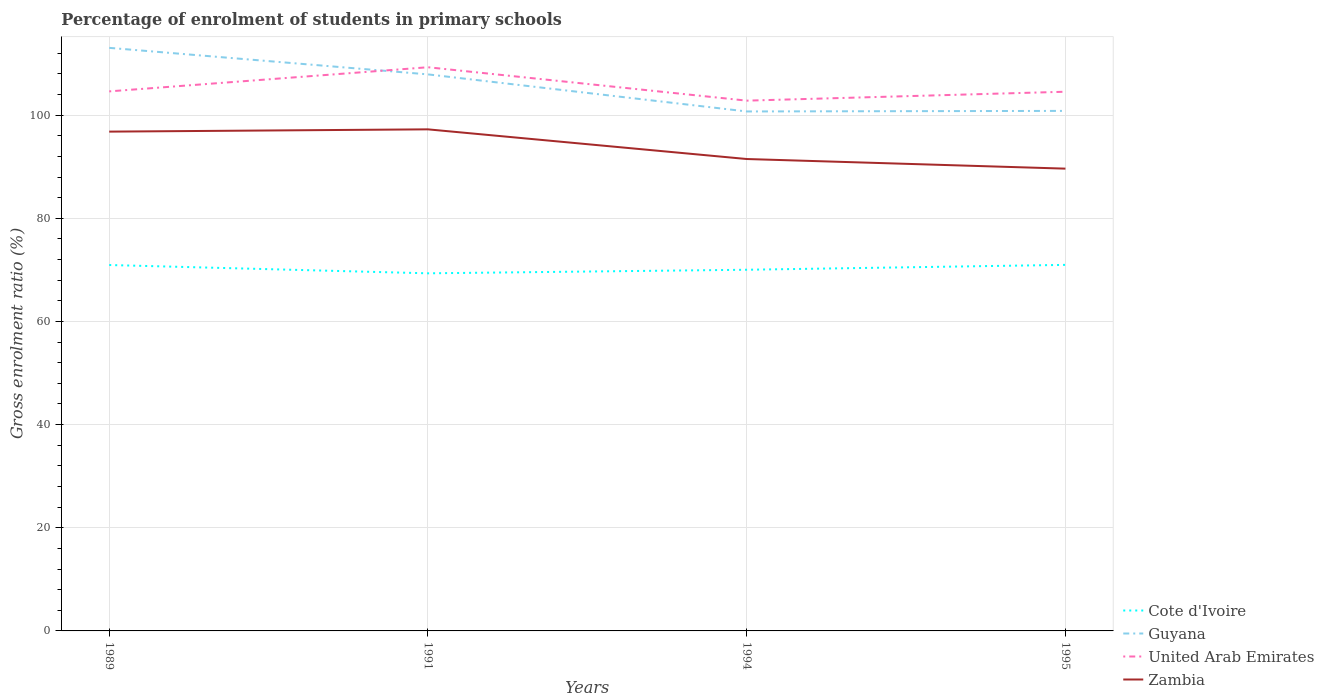How many different coloured lines are there?
Make the answer very short. 4. Is the number of lines equal to the number of legend labels?
Give a very brief answer. Yes. Across all years, what is the maximum percentage of students enrolled in primary schools in United Arab Emirates?
Provide a short and direct response. 102.82. What is the total percentage of students enrolled in primary schools in Zambia in the graph?
Offer a very short reply. 5.31. What is the difference between the highest and the second highest percentage of students enrolled in primary schools in Zambia?
Keep it short and to the point. 7.62. What is the difference between the highest and the lowest percentage of students enrolled in primary schools in Zambia?
Provide a short and direct response. 2. Is the percentage of students enrolled in primary schools in Cote d'Ivoire strictly greater than the percentage of students enrolled in primary schools in Zambia over the years?
Give a very brief answer. Yes. How many lines are there?
Provide a short and direct response. 4. How many years are there in the graph?
Your answer should be compact. 4. What is the difference between two consecutive major ticks on the Y-axis?
Your answer should be very brief. 20. Does the graph contain any zero values?
Your response must be concise. No. Does the graph contain grids?
Make the answer very short. Yes. How many legend labels are there?
Offer a very short reply. 4. What is the title of the graph?
Keep it short and to the point. Percentage of enrolment of students in primary schools. Does "Turkmenistan" appear as one of the legend labels in the graph?
Offer a very short reply. No. What is the label or title of the Y-axis?
Make the answer very short. Gross enrolment ratio (%). What is the Gross enrolment ratio (%) in Cote d'Ivoire in 1989?
Offer a terse response. 70.95. What is the Gross enrolment ratio (%) in Guyana in 1989?
Provide a succinct answer. 113.06. What is the Gross enrolment ratio (%) of United Arab Emirates in 1989?
Keep it short and to the point. 104.62. What is the Gross enrolment ratio (%) in Zambia in 1989?
Offer a terse response. 96.81. What is the Gross enrolment ratio (%) in Cote d'Ivoire in 1991?
Ensure brevity in your answer.  69.34. What is the Gross enrolment ratio (%) in Guyana in 1991?
Provide a succinct answer. 107.91. What is the Gross enrolment ratio (%) of United Arab Emirates in 1991?
Provide a short and direct response. 109.3. What is the Gross enrolment ratio (%) in Zambia in 1991?
Offer a terse response. 97.25. What is the Gross enrolment ratio (%) of Cote d'Ivoire in 1994?
Provide a short and direct response. 70.03. What is the Gross enrolment ratio (%) of Guyana in 1994?
Give a very brief answer. 100.72. What is the Gross enrolment ratio (%) in United Arab Emirates in 1994?
Your answer should be compact. 102.82. What is the Gross enrolment ratio (%) in Zambia in 1994?
Keep it short and to the point. 91.5. What is the Gross enrolment ratio (%) of Cote d'Ivoire in 1995?
Make the answer very short. 70.98. What is the Gross enrolment ratio (%) in Guyana in 1995?
Keep it short and to the point. 100.83. What is the Gross enrolment ratio (%) in United Arab Emirates in 1995?
Keep it short and to the point. 104.55. What is the Gross enrolment ratio (%) in Zambia in 1995?
Your answer should be compact. 89.64. Across all years, what is the maximum Gross enrolment ratio (%) of Cote d'Ivoire?
Ensure brevity in your answer.  70.98. Across all years, what is the maximum Gross enrolment ratio (%) of Guyana?
Ensure brevity in your answer.  113.06. Across all years, what is the maximum Gross enrolment ratio (%) of United Arab Emirates?
Make the answer very short. 109.3. Across all years, what is the maximum Gross enrolment ratio (%) of Zambia?
Give a very brief answer. 97.25. Across all years, what is the minimum Gross enrolment ratio (%) in Cote d'Ivoire?
Your answer should be compact. 69.34. Across all years, what is the minimum Gross enrolment ratio (%) in Guyana?
Ensure brevity in your answer.  100.72. Across all years, what is the minimum Gross enrolment ratio (%) in United Arab Emirates?
Your answer should be very brief. 102.82. Across all years, what is the minimum Gross enrolment ratio (%) in Zambia?
Ensure brevity in your answer.  89.64. What is the total Gross enrolment ratio (%) of Cote d'Ivoire in the graph?
Provide a short and direct response. 281.3. What is the total Gross enrolment ratio (%) in Guyana in the graph?
Your answer should be very brief. 422.53. What is the total Gross enrolment ratio (%) in United Arab Emirates in the graph?
Provide a succinct answer. 421.28. What is the total Gross enrolment ratio (%) in Zambia in the graph?
Offer a terse response. 375.21. What is the difference between the Gross enrolment ratio (%) of Cote d'Ivoire in 1989 and that in 1991?
Make the answer very short. 1.61. What is the difference between the Gross enrolment ratio (%) of Guyana in 1989 and that in 1991?
Keep it short and to the point. 5.15. What is the difference between the Gross enrolment ratio (%) in United Arab Emirates in 1989 and that in 1991?
Your response must be concise. -4.68. What is the difference between the Gross enrolment ratio (%) of Zambia in 1989 and that in 1991?
Ensure brevity in your answer.  -0.44. What is the difference between the Gross enrolment ratio (%) of Cote d'Ivoire in 1989 and that in 1994?
Provide a short and direct response. 0.92. What is the difference between the Gross enrolment ratio (%) in Guyana in 1989 and that in 1994?
Offer a terse response. 12.33. What is the difference between the Gross enrolment ratio (%) in United Arab Emirates in 1989 and that in 1994?
Provide a succinct answer. 1.8. What is the difference between the Gross enrolment ratio (%) in Zambia in 1989 and that in 1994?
Offer a terse response. 5.31. What is the difference between the Gross enrolment ratio (%) in Cote d'Ivoire in 1989 and that in 1995?
Give a very brief answer. -0.03. What is the difference between the Gross enrolment ratio (%) in Guyana in 1989 and that in 1995?
Give a very brief answer. 12.22. What is the difference between the Gross enrolment ratio (%) in United Arab Emirates in 1989 and that in 1995?
Make the answer very short. 0.07. What is the difference between the Gross enrolment ratio (%) in Zambia in 1989 and that in 1995?
Give a very brief answer. 7.18. What is the difference between the Gross enrolment ratio (%) in Cote d'Ivoire in 1991 and that in 1994?
Your answer should be compact. -0.69. What is the difference between the Gross enrolment ratio (%) of Guyana in 1991 and that in 1994?
Give a very brief answer. 7.19. What is the difference between the Gross enrolment ratio (%) in United Arab Emirates in 1991 and that in 1994?
Your answer should be compact. 6.48. What is the difference between the Gross enrolment ratio (%) in Zambia in 1991 and that in 1994?
Your response must be concise. 5.75. What is the difference between the Gross enrolment ratio (%) in Cote d'Ivoire in 1991 and that in 1995?
Make the answer very short. -1.64. What is the difference between the Gross enrolment ratio (%) of Guyana in 1991 and that in 1995?
Keep it short and to the point. 7.08. What is the difference between the Gross enrolment ratio (%) of United Arab Emirates in 1991 and that in 1995?
Ensure brevity in your answer.  4.75. What is the difference between the Gross enrolment ratio (%) in Zambia in 1991 and that in 1995?
Provide a short and direct response. 7.62. What is the difference between the Gross enrolment ratio (%) of Cote d'Ivoire in 1994 and that in 1995?
Your answer should be compact. -0.95. What is the difference between the Gross enrolment ratio (%) in Guyana in 1994 and that in 1995?
Keep it short and to the point. -0.11. What is the difference between the Gross enrolment ratio (%) in United Arab Emirates in 1994 and that in 1995?
Provide a short and direct response. -1.73. What is the difference between the Gross enrolment ratio (%) in Zambia in 1994 and that in 1995?
Offer a very short reply. 1.87. What is the difference between the Gross enrolment ratio (%) in Cote d'Ivoire in 1989 and the Gross enrolment ratio (%) in Guyana in 1991?
Offer a terse response. -36.96. What is the difference between the Gross enrolment ratio (%) of Cote d'Ivoire in 1989 and the Gross enrolment ratio (%) of United Arab Emirates in 1991?
Ensure brevity in your answer.  -38.35. What is the difference between the Gross enrolment ratio (%) of Cote d'Ivoire in 1989 and the Gross enrolment ratio (%) of Zambia in 1991?
Your answer should be compact. -26.31. What is the difference between the Gross enrolment ratio (%) in Guyana in 1989 and the Gross enrolment ratio (%) in United Arab Emirates in 1991?
Give a very brief answer. 3.76. What is the difference between the Gross enrolment ratio (%) of Guyana in 1989 and the Gross enrolment ratio (%) of Zambia in 1991?
Provide a succinct answer. 15.8. What is the difference between the Gross enrolment ratio (%) of United Arab Emirates in 1989 and the Gross enrolment ratio (%) of Zambia in 1991?
Offer a terse response. 7.36. What is the difference between the Gross enrolment ratio (%) of Cote d'Ivoire in 1989 and the Gross enrolment ratio (%) of Guyana in 1994?
Your response must be concise. -29.77. What is the difference between the Gross enrolment ratio (%) of Cote d'Ivoire in 1989 and the Gross enrolment ratio (%) of United Arab Emirates in 1994?
Make the answer very short. -31.87. What is the difference between the Gross enrolment ratio (%) of Cote d'Ivoire in 1989 and the Gross enrolment ratio (%) of Zambia in 1994?
Provide a short and direct response. -20.55. What is the difference between the Gross enrolment ratio (%) of Guyana in 1989 and the Gross enrolment ratio (%) of United Arab Emirates in 1994?
Make the answer very short. 10.24. What is the difference between the Gross enrolment ratio (%) of Guyana in 1989 and the Gross enrolment ratio (%) of Zambia in 1994?
Your response must be concise. 21.55. What is the difference between the Gross enrolment ratio (%) in United Arab Emirates in 1989 and the Gross enrolment ratio (%) in Zambia in 1994?
Offer a terse response. 13.11. What is the difference between the Gross enrolment ratio (%) of Cote d'Ivoire in 1989 and the Gross enrolment ratio (%) of Guyana in 1995?
Offer a terse response. -29.88. What is the difference between the Gross enrolment ratio (%) in Cote d'Ivoire in 1989 and the Gross enrolment ratio (%) in United Arab Emirates in 1995?
Make the answer very short. -33.6. What is the difference between the Gross enrolment ratio (%) of Cote d'Ivoire in 1989 and the Gross enrolment ratio (%) of Zambia in 1995?
Your answer should be compact. -18.69. What is the difference between the Gross enrolment ratio (%) in Guyana in 1989 and the Gross enrolment ratio (%) in United Arab Emirates in 1995?
Ensure brevity in your answer.  8.51. What is the difference between the Gross enrolment ratio (%) in Guyana in 1989 and the Gross enrolment ratio (%) in Zambia in 1995?
Provide a succinct answer. 23.42. What is the difference between the Gross enrolment ratio (%) in United Arab Emirates in 1989 and the Gross enrolment ratio (%) in Zambia in 1995?
Your response must be concise. 14.98. What is the difference between the Gross enrolment ratio (%) of Cote d'Ivoire in 1991 and the Gross enrolment ratio (%) of Guyana in 1994?
Your answer should be compact. -31.38. What is the difference between the Gross enrolment ratio (%) in Cote d'Ivoire in 1991 and the Gross enrolment ratio (%) in United Arab Emirates in 1994?
Offer a very short reply. -33.48. What is the difference between the Gross enrolment ratio (%) of Cote d'Ivoire in 1991 and the Gross enrolment ratio (%) of Zambia in 1994?
Your answer should be very brief. -22.16. What is the difference between the Gross enrolment ratio (%) in Guyana in 1991 and the Gross enrolment ratio (%) in United Arab Emirates in 1994?
Your answer should be very brief. 5.09. What is the difference between the Gross enrolment ratio (%) of Guyana in 1991 and the Gross enrolment ratio (%) of Zambia in 1994?
Keep it short and to the point. 16.41. What is the difference between the Gross enrolment ratio (%) of United Arab Emirates in 1991 and the Gross enrolment ratio (%) of Zambia in 1994?
Offer a terse response. 17.79. What is the difference between the Gross enrolment ratio (%) of Cote d'Ivoire in 1991 and the Gross enrolment ratio (%) of Guyana in 1995?
Provide a succinct answer. -31.49. What is the difference between the Gross enrolment ratio (%) of Cote d'Ivoire in 1991 and the Gross enrolment ratio (%) of United Arab Emirates in 1995?
Offer a very short reply. -35.21. What is the difference between the Gross enrolment ratio (%) in Cote d'Ivoire in 1991 and the Gross enrolment ratio (%) in Zambia in 1995?
Offer a very short reply. -20.3. What is the difference between the Gross enrolment ratio (%) of Guyana in 1991 and the Gross enrolment ratio (%) of United Arab Emirates in 1995?
Your answer should be compact. 3.36. What is the difference between the Gross enrolment ratio (%) of Guyana in 1991 and the Gross enrolment ratio (%) of Zambia in 1995?
Make the answer very short. 18.28. What is the difference between the Gross enrolment ratio (%) of United Arab Emirates in 1991 and the Gross enrolment ratio (%) of Zambia in 1995?
Offer a terse response. 19.66. What is the difference between the Gross enrolment ratio (%) in Cote d'Ivoire in 1994 and the Gross enrolment ratio (%) in Guyana in 1995?
Offer a very short reply. -30.8. What is the difference between the Gross enrolment ratio (%) in Cote d'Ivoire in 1994 and the Gross enrolment ratio (%) in United Arab Emirates in 1995?
Ensure brevity in your answer.  -34.52. What is the difference between the Gross enrolment ratio (%) of Cote d'Ivoire in 1994 and the Gross enrolment ratio (%) of Zambia in 1995?
Offer a terse response. -19.61. What is the difference between the Gross enrolment ratio (%) in Guyana in 1994 and the Gross enrolment ratio (%) in United Arab Emirates in 1995?
Provide a short and direct response. -3.83. What is the difference between the Gross enrolment ratio (%) of Guyana in 1994 and the Gross enrolment ratio (%) of Zambia in 1995?
Offer a terse response. 11.09. What is the difference between the Gross enrolment ratio (%) in United Arab Emirates in 1994 and the Gross enrolment ratio (%) in Zambia in 1995?
Offer a terse response. 13.18. What is the average Gross enrolment ratio (%) in Cote d'Ivoire per year?
Offer a terse response. 70.32. What is the average Gross enrolment ratio (%) of Guyana per year?
Provide a short and direct response. 105.63. What is the average Gross enrolment ratio (%) of United Arab Emirates per year?
Keep it short and to the point. 105.32. What is the average Gross enrolment ratio (%) in Zambia per year?
Make the answer very short. 93.8. In the year 1989, what is the difference between the Gross enrolment ratio (%) of Cote d'Ivoire and Gross enrolment ratio (%) of Guyana?
Ensure brevity in your answer.  -42.11. In the year 1989, what is the difference between the Gross enrolment ratio (%) of Cote d'Ivoire and Gross enrolment ratio (%) of United Arab Emirates?
Keep it short and to the point. -33.67. In the year 1989, what is the difference between the Gross enrolment ratio (%) in Cote d'Ivoire and Gross enrolment ratio (%) in Zambia?
Provide a short and direct response. -25.86. In the year 1989, what is the difference between the Gross enrolment ratio (%) of Guyana and Gross enrolment ratio (%) of United Arab Emirates?
Ensure brevity in your answer.  8.44. In the year 1989, what is the difference between the Gross enrolment ratio (%) of Guyana and Gross enrolment ratio (%) of Zambia?
Your answer should be very brief. 16.24. In the year 1989, what is the difference between the Gross enrolment ratio (%) in United Arab Emirates and Gross enrolment ratio (%) in Zambia?
Ensure brevity in your answer.  7.8. In the year 1991, what is the difference between the Gross enrolment ratio (%) of Cote d'Ivoire and Gross enrolment ratio (%) of Guyana?
Your response must be concise. -38.57. In the year 1991, what is the difference between the Gross enrolment ratio (%) in Cote d'Ivoire and Gross enrolment ratio (%) in United Arab Emirates?
Make the answer very short. -39.96. In the year 1991, what is the difference between the Gross enrolment ratio (%) in Cote d'Ivoire and Gross enrolment ratio (%) in Zambia?
Provide a succinct answer. -27.91. In the year 1991, what is the difference between the Gross enrolment ratio (%) of Guyana and Gross enrolment ratio (%) of United Arab Emirates?
Your answer should be compact. -1.38. In the year 1991, what is the difference between the Gross enrolment ratio (%) of Guyana and Gross enrolment ratio (%) of Zambia?
Your answer should be compact. 10.66. In the year 1991, what is the difference between the Gross enrolment ratio (%) in United Arab Emirates and Gross enrolment ratio (%) in Zambia?
Your answer should be very brief. 12.04. In the year 1994, what is the difference between the Gross enrolment ratio (%) of Cote d'Ivoire and Gross enrolment ratio (%) of Guyana?
Keep it short and to the point. -30.69. In the year 1994, what is the difference between the Gross enrolment ratio (%) in Cote d'Ivoire and Gross enrolment ratio (%) in United Arab Emirates?
Offer a terse response. -32.79. In the year 1994, what is the difference between the Gross enrolment ratio (%) in Cote d'Ivoire and Gross enrolment ratio (%) in Zambia?
Ensure brevity in your answer.  -21.47. In the year 1994, what is the difference between the Gross enrolment ratio (%) of Guyana and Gross enrolment ratio (%) of United Arab Emirates?
Your answer should be compact. -2.1. In the year 1994, what is the difference between the Gross enrolment ratio (%) in Guyana and Gross enrolment ratio (%) in Zambia?
Your response must be concise. 9.22. In the year 1994, what is the difference between the Gross enrolment ratio (%) of United Arab Emirates and Gross enrolment ratio (%) of Zambia?
Keep it short and to the point. 11.32. In the year 1995, what is the difference between the Gross enrolment ratio (%) of Cote d'Ivoire and Gross enrolment ratio (%) of Guyana?
Make the answer very short. -29.85. In the year 1995, what is the difference between the Gross enrolment ratio (%) of Cote d'Ivoire and Gross enrolment ratio (%) of United Arab Emirates?
Provide a short and direct response. -33.57. In the year 1995, what is the difference between the Gross enrolment ratio (%) of Cote d'Ivoire and Gross enrolment ratio (%) of Zambia?
Provide a short and direct response. -18.66. In the year 1995, what is the difference between the Gross enrolment ratio (%) of Guyana and Gross enrolment ratio (%) of United Arab Emirates?
Your response must be concise. -3.72. In the year 1995, what is the difference between the Gross enrolment ratio (%) of Guyana and Gross enrolment ratio (%) of Zambia?
Keep it short and to the point. 11.2. In the year 1995, what is the difference between the Gross enrolment ratio (%) in United Arab Emirates and Gross enrolment ratio (%) in Zambia?
Ensure brevity in your answer.  14.91. What is the ratio of the Gross enrolment ratio (%) in Cote d'Ivoire in 1989 to that in 1991?
Your answer should be compact. 1.02. What is the ratio of the Gross enrolment ratio (%) of Guyana in 1989 to that in 1991?
Keep it short and to the point. 1.05. What is the ratio of the Gross enrolment ratio (%) of United Arab Emirates in 1989 to that in 1991?
Your answer should be very brief. 0.96. What is the ratio of the Gross enrolment ratio (%) in Zambia in 1989 to that in 1991?
Make the answer very short. 1. What is the ratio of the Gross enrolment ratio (%) in Cote d'Ivoire in 1989 to that in 1994?
Your response must be concise. 1.01. What is the ratio of the Gross enrolment ratio (%) of Guyana in 1989 to that in 1994?
Provide a short and direct response. 1.12. What is the ratio of the Gross enrolment ratio (%) in United Arab Emirates in 1989 to that in 1994?
Give a very brief answer. 1.02. What is the ratio of the Gross enrolment ratio (%) of Zambia in 1989 to that in 1994?
Your answer should be compact. 1.06. What is the ratio of the Gross enrolment ratio (%) in Guyana in 1989 to that in 1995?
Your answer should be very brief. 1.12. What is the ratio of the Gross enrolment ratio (%) in United Arab Emirates in 1989 to that in 1995?
Offer a terse response. 1. What is the ratio of the Gross enrolment ratio (%) in Zambia in 1989 to that in 1995?
Your answer should be compact. 1.08. What is the ratio of the Gross enrolment ratio (%) in Cote d'Ivoire in 1991 to that in 1994?
Your answer should be very brief. 0.99. What is the ratio of the Gross enrolment ratio (%) in Guyana in 1991 to that in 1994?
Make the answer very short. 1.07. What is the ratio of the Gross enrolment ratio (%) of United Arab Emirates in 1991 to that in 1994?
Provide a short and direct response. 1.06. What is the ratio of the Gross enrolment ratio (%) of Zambia in 1991 to that in 1994?
Make the answer very short. 1.06. What is the ratio of the Gross enrolment ratio (%) of Cote d'Ivoire in 1991 to that in 1995?
Offer a very short reply. 0.98. What is the ratio of the Gross enrolment ratio (%) of Guyana in 1991 to that in 1995?
Make the answer very short. 1.07. What is the ratio of the Gross enrolment ratio (%) of United Arab Emirates in 1991 to that in 1995?
Ensure brevity in your answer.  1.05. What is the ratio of the Gross enrolment ratio (%) of Zambia in 1991 to that in 1995?
Provide a succinct answer. 1.08. What is the ratio of the Gross enrolment ratio (%) of Cote d'Ivoire in 1994 to that in 1995?
Give a very brief answer. 0.99. What is the ratio of the Gross enrolment ratio (%) of United Arab Emirates in 1994 to that in 1995?
Offer a terse response. 0.98. What is the ratio of the Gross enrolment ratio (%) in Zambia in 1994 to that in 1995?
Give a very brief answer. 1.02. What is the difference between the highest and the second highest Gross enrolment ratio (%) of Cote d'Ivoire?
Keep it short and to the point. 0.03. What is the difference between the highest and the second highest Gross enrolment ratio (%) in Guyana?
Give a very brief answer. 5.15. What is the difference between the highest and the second highest Gross enrolment ratio (%) in United Arab Emirates?
Your answer should be compact. 4.68. What is the difference between the highest and the second highest Gross enrolment ratio (%) in Zambia?
Make the answer very short. 0.44. What is the difference between the highest and the lowest Gross enrolment ratio (%) of Cote d'Ivoire?
Give a very brief answer. 1.64. What is the difference between the highest and the lowest Gross enrolment ratio (%) of Guyana?
Ensure brevity in your answer.  12.33. What is the difference between the highest and the lowest Gross enrolment ratio (%) in United Arab Emirates?
Offer a very short reply. 6.48. What is the difference between the highest and the lowest Gross enrolment ratio (%) of Zambia?
Provide a short and direct response. 7.62. 